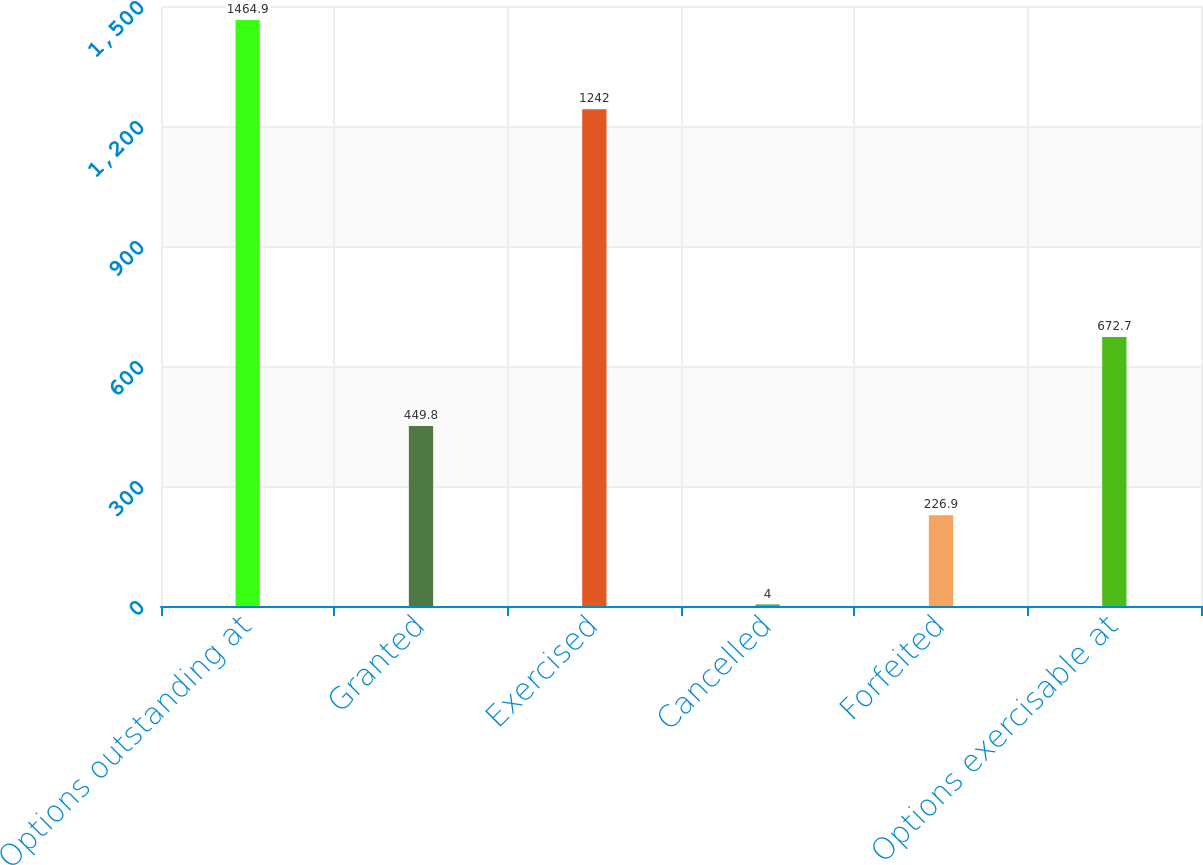Convert chart to OTSL. <chart><loc_0><loc_0><loc_500><loc_500><bar_chart><fcel>Options outstanding at<fcel>Granted<fcel>Exercised<fcel>Cancelled<fcel>Forfeited<fcel>Options exercisable at<nl><fcel>1464.9<fcel>449.8<fcel>1242<fcel>4<fcel>226.9<fcel>672.7<nl></chart> 